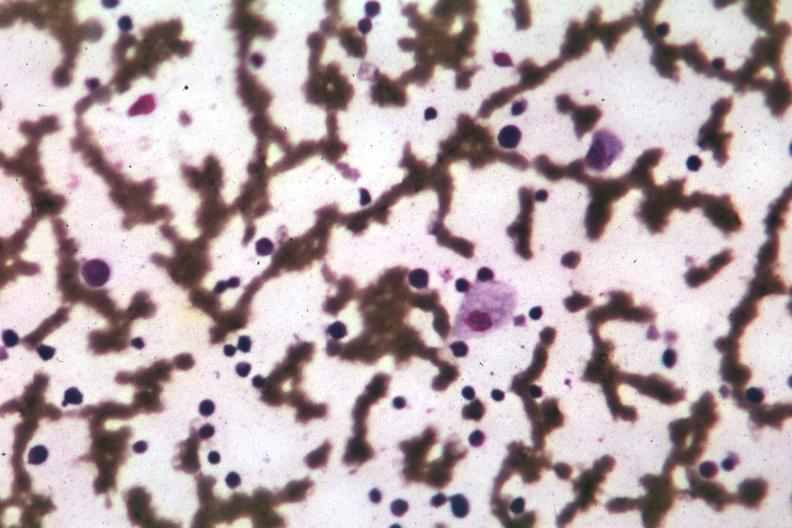what easily seen?
Answer the question using a single word or phrase. Wrights single cell 